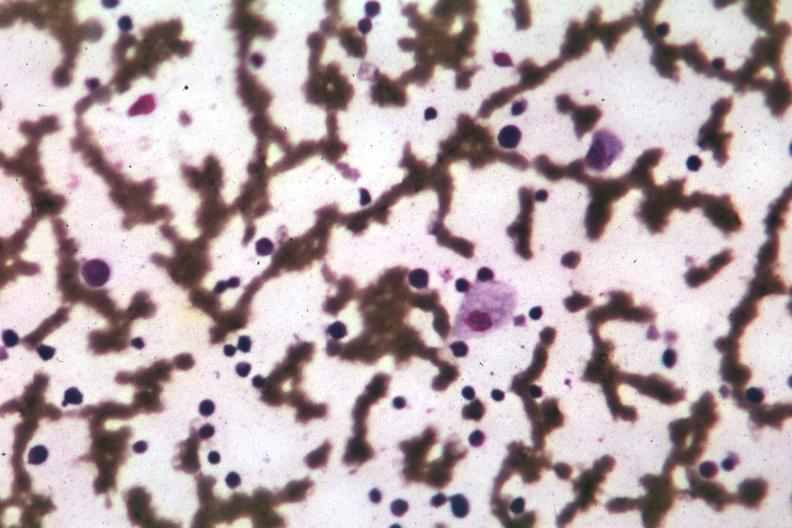what easily seen?
Answer the question using a single word or phrase. Wrights single cell 